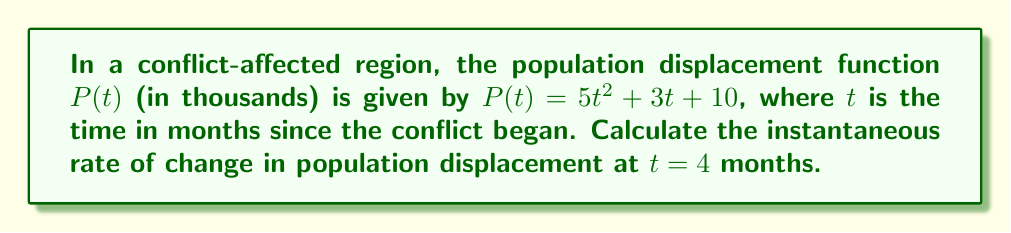Provide a solution to this math problem. To find the instantaneous rate of change in population displacement at $t = 4$ months, we need to calculate the derivative of the function $P(t)$ and evaluate it at $t = 4$.

1. Given function: $P(t) = 5t^2 + 3t + 10$

2. To find the derivative $P'(t)$, we apply the power rule and constant rule:
   $P'(t) = 10t + 3$

3. Now, we evaluate $P'(t)$ at $t = 4$:
   $P'(4) = 10(4) + 3 = 40 + 3 = 43$

The instantaneous rate of change at $t = 4$ months is 43 thousand people per month.

This means that at exactly 4 months after the conflict began, the population displacement was increasing at a rate of 43,000 people per month.
Answer: 43 thousand people per month 